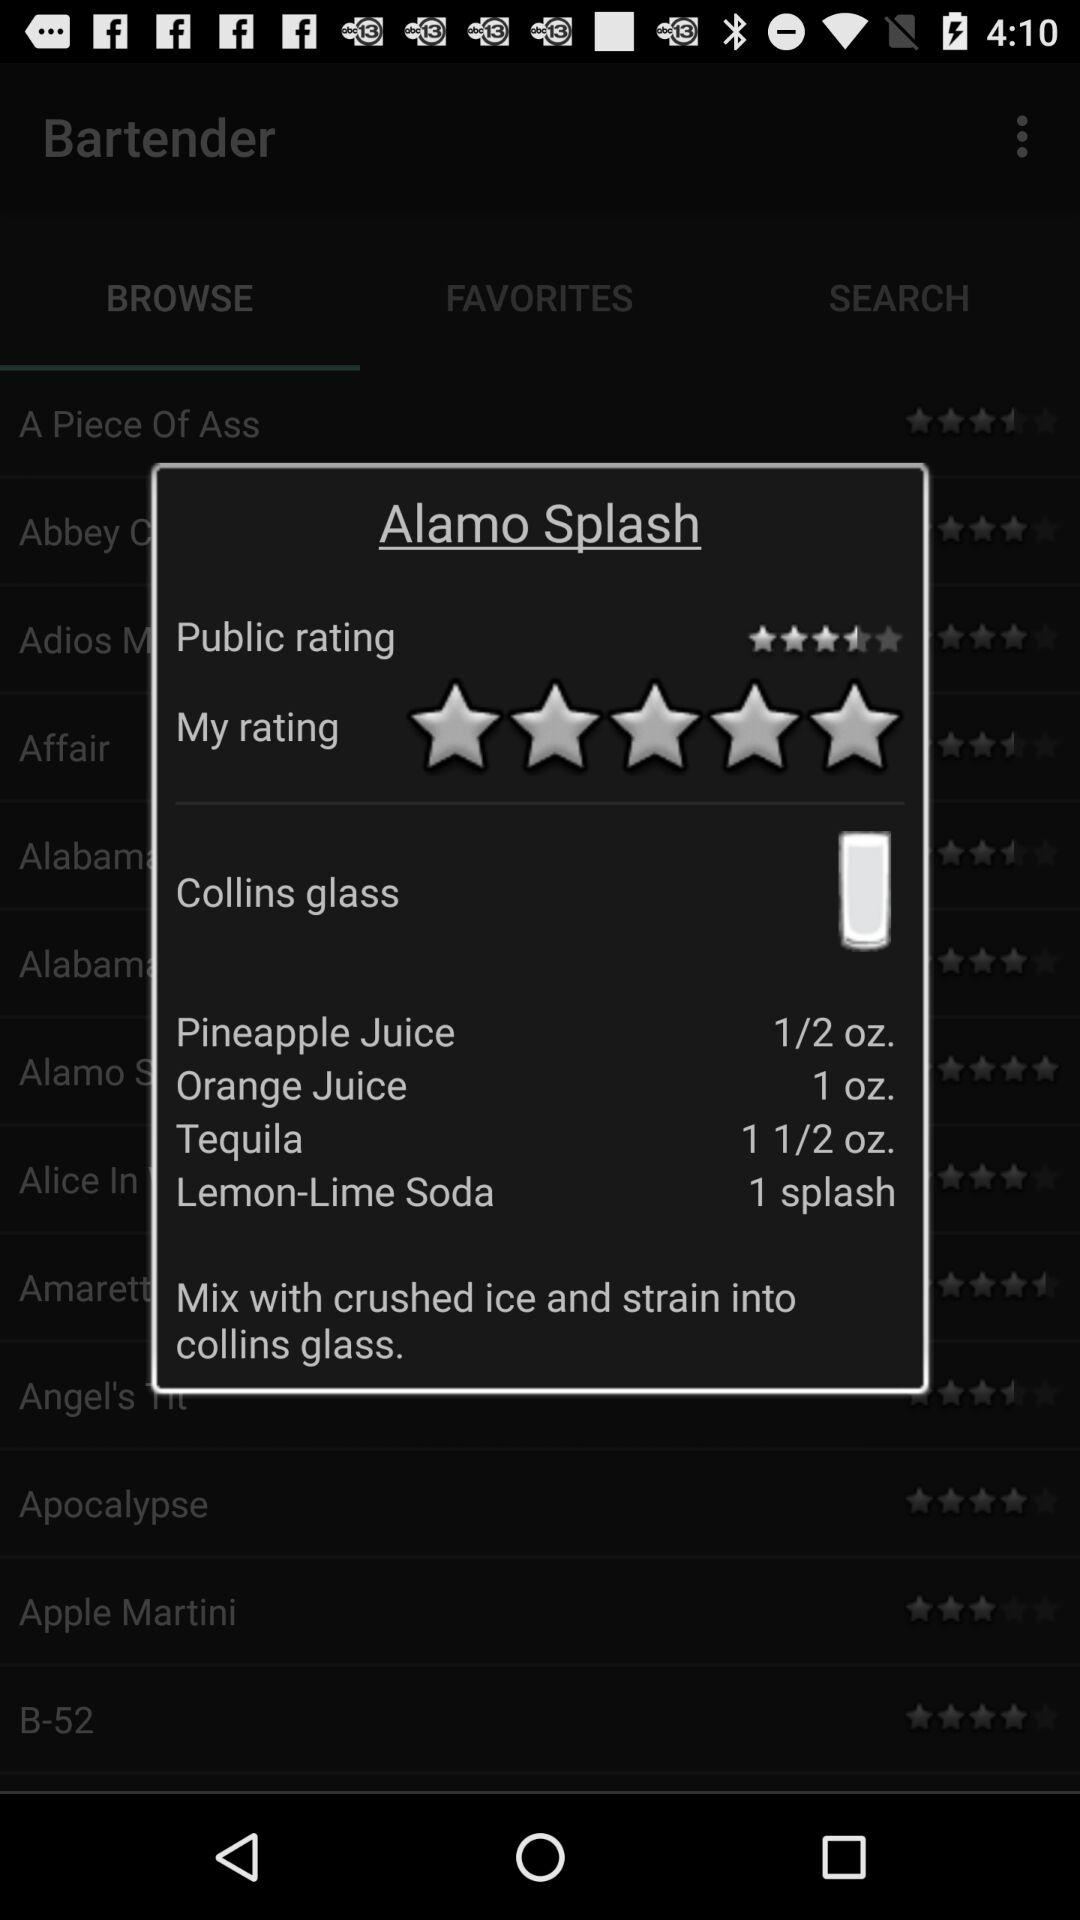What are the ingredients required for the Alamo Splash? The ingredients required are "Pineapple Juice", "Orange Juice", "Tequila" and "Lemon-Lime Soda". 